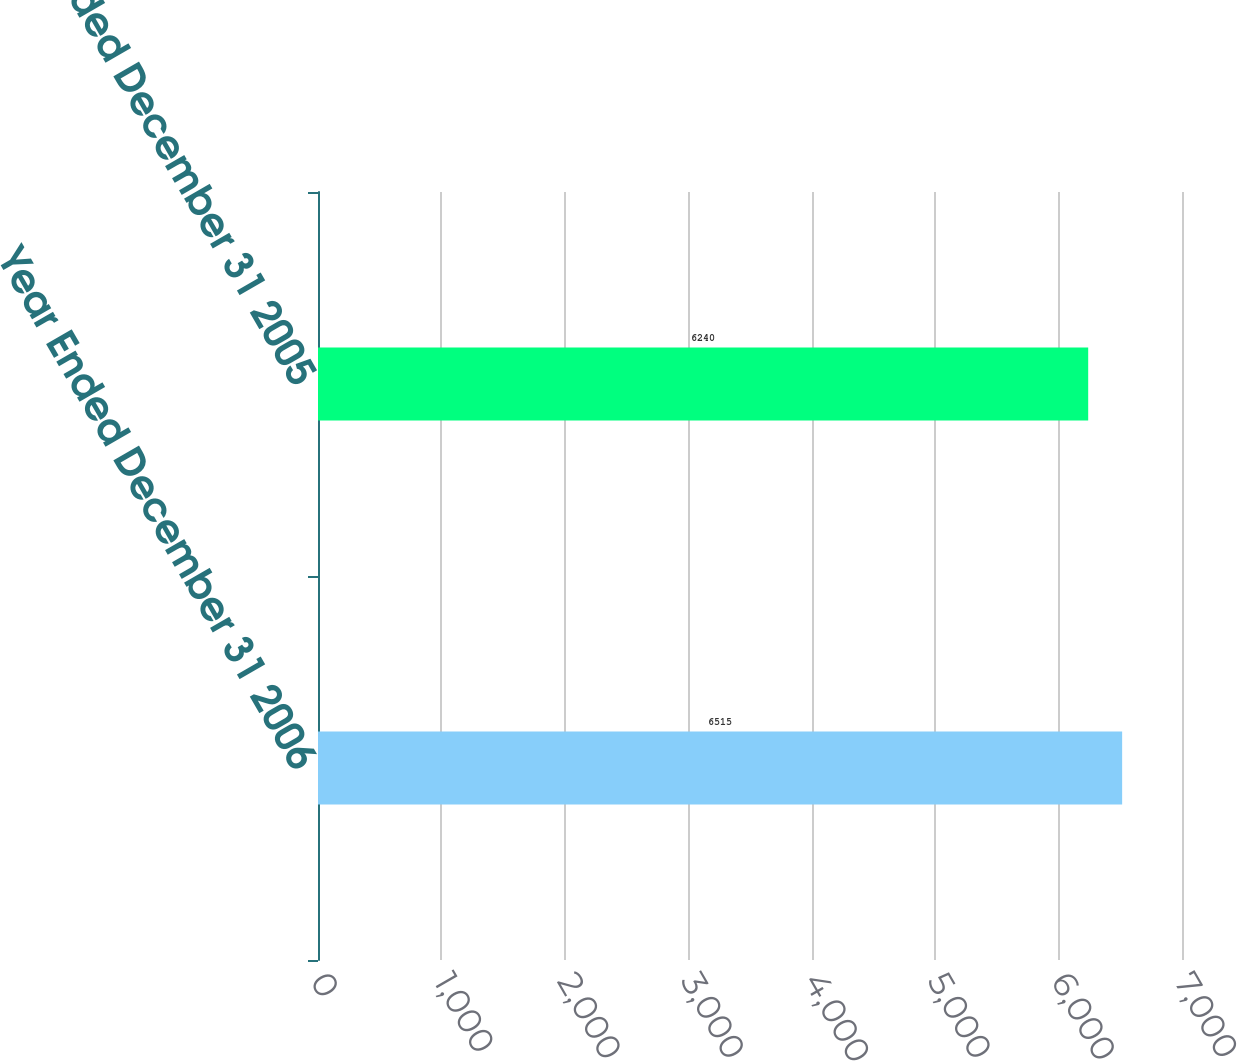Convert chart. <chart><loc_0><loc_0><loc_500><loc_500><bar_chart><fcel>Year Ended December 31 2006<fcel>Year Ended December 31 2005<nl><fcel>6515<fcel>6240<nl></chart> 